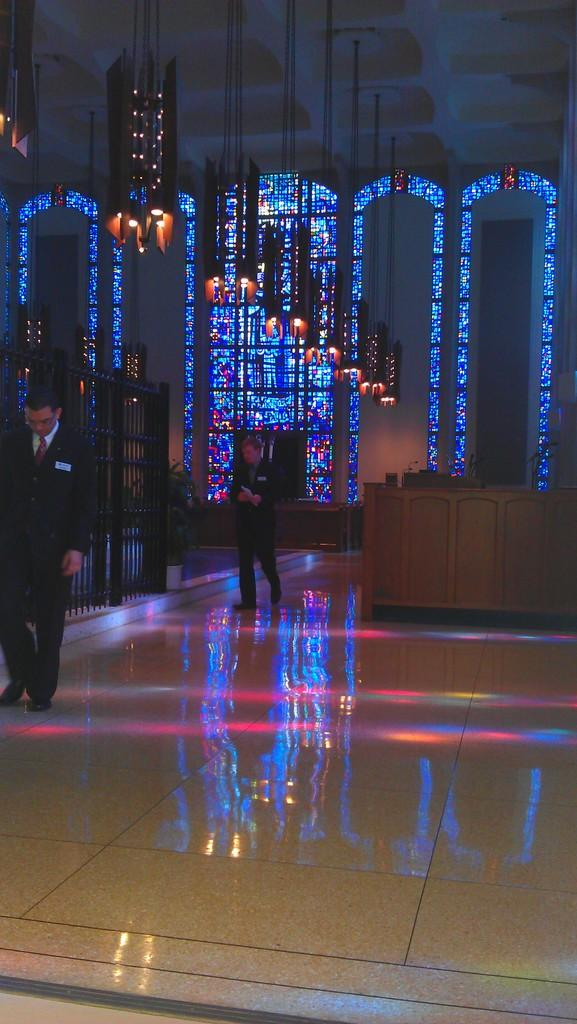How many people are in the image? There are two people standing in the image. What can be seen in the image besides the people? There are lights or lamps in the image. Where are the lights or lamps located in the image? The lights or lamps are near the roof. How does the brush affect the beggar in the image? There is no brush or beggar present in the image. 